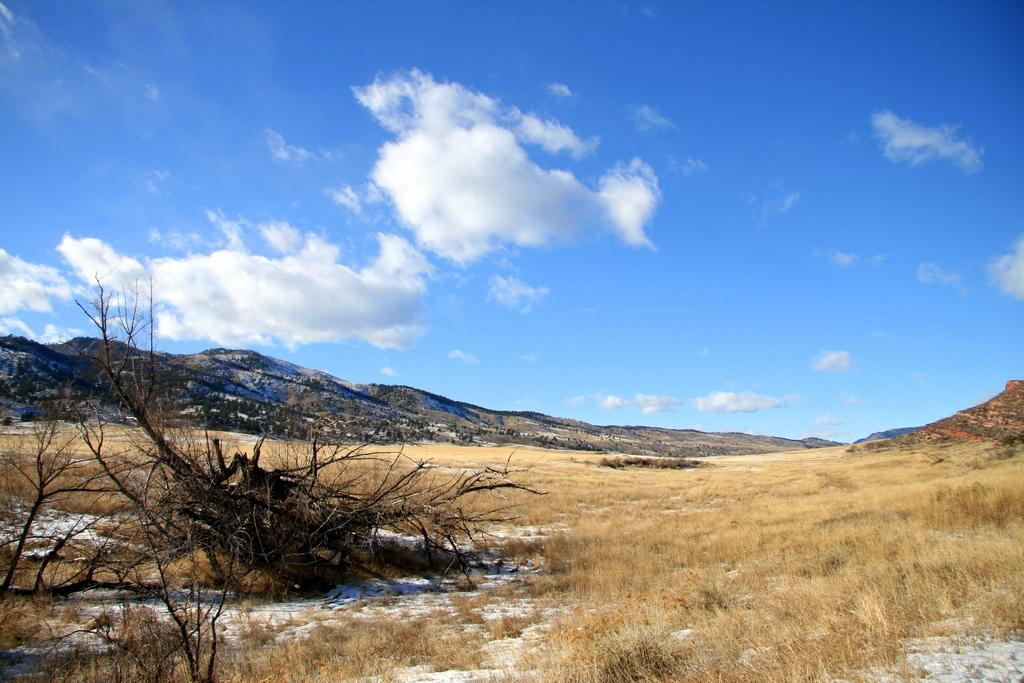What type of vegetation can be seen in the image? There are dried trees and dried grass in the image. What can be seen in the background of the image? Hills are visible in the background of the image. What is visible in the sky in the image? The sky is visible in the image, and clouds are present. What type of engine is powering the vehicle in the image? There is no vehicle or engine present in the image. 